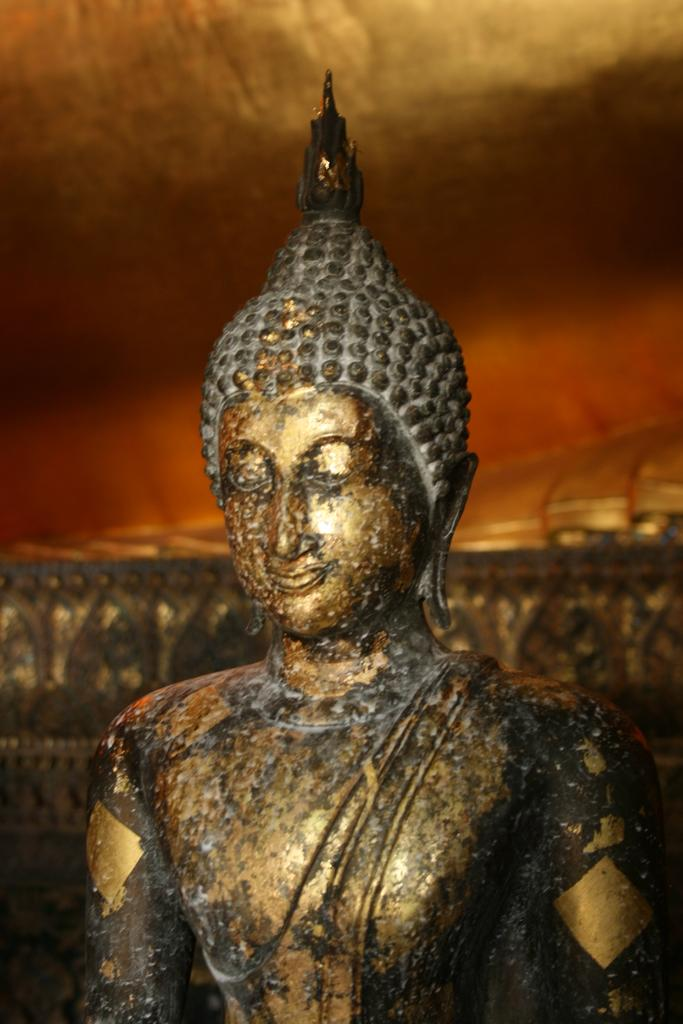What is the main subject of the image? There is a sculpture in the image. Can you describe the sculpture? Unfortunately, the facts provided do not give any details about the sculpture's appearance or characteristics. What can be seen in the background of the image? There are objects visible in the background of the image. How many feet are visible on the sculpture in the image? There is no information about the sculpture's appearance or features, so it is impossible to determine if any feet are visible. Is there any blood visible on the sculpture in the image? There is no information about the sculpture's appearance or features, so it is impossible to determine if any blood is visible. 